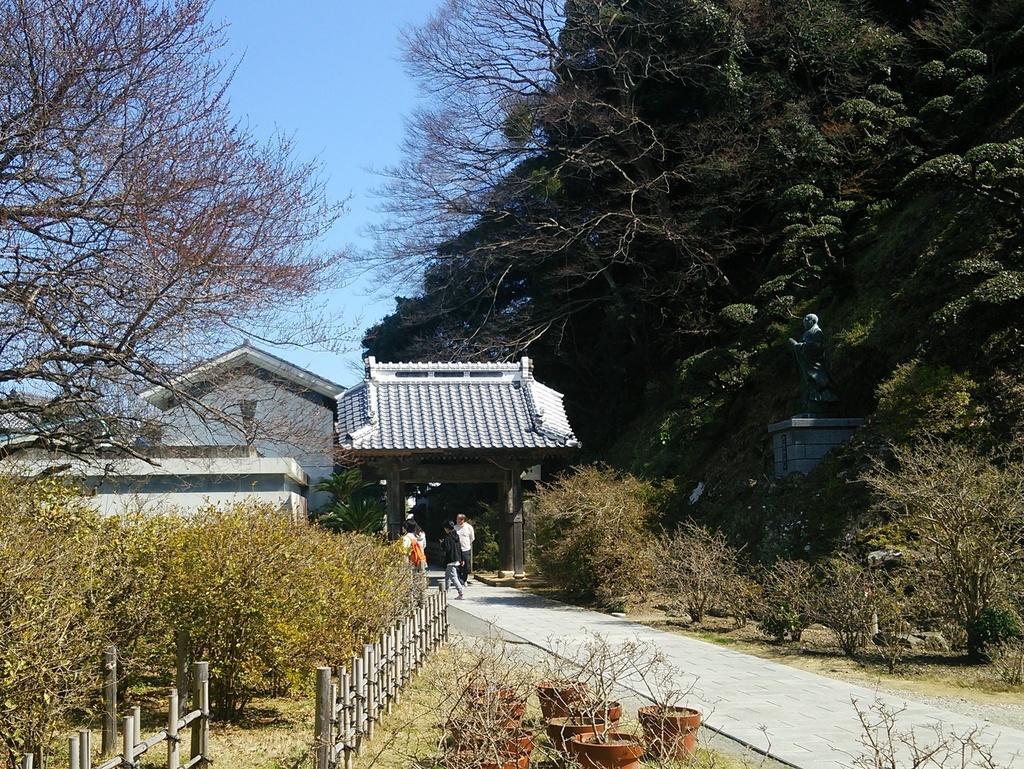Could you give a brief overview of what you see in this image? In this image we can see some plants and trees and there are some people walking on a path and beside the path we can see some flower pots and we can see the fence. On the right side, we can see a statue and in the background, we can see the house and the sky. 